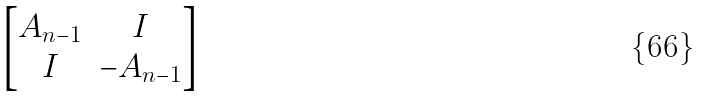<formula> <loc_0><loc_0><loc_500><loc_500>\begin{bmatrix} A _ { n - 1 } & I \\ I & - A _ { n - 1 } \end{bmatrix}</formula> 